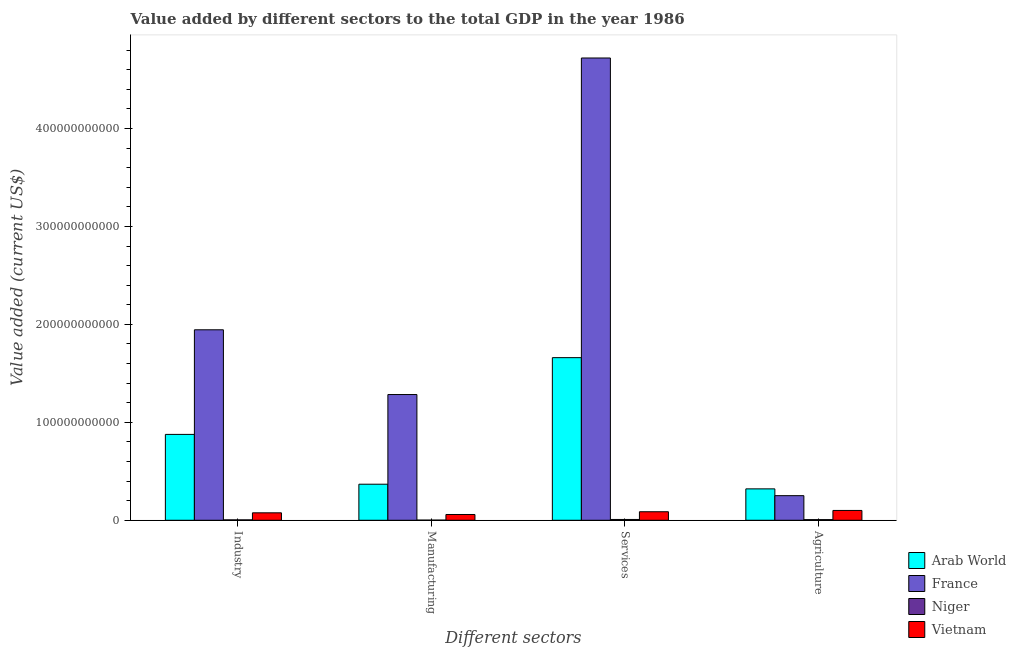How many different coloured bars are there?
Provide a succinct answer. 4. How many groups of bars are there?
Keep it short and to the point. 4. How many bars are there on the 3rd tick from the left?
Your response must be concise. 4. How many bars are there on the 1st tick from the right?
Your answer should be very brief. 4. What is the label of the 4th group of bars from the left?
Ensure brevity in your answer.  Agriculture. What is the value added by manufacturing sector in Vietnam?
Provide a short and direct response. 5.89e+09. Across all countries, what is the maximum value added by manufacturing sector?
Ensure brevity in your answer.  1.28e+11. Across all countries, what is the minimum value added by services sector?
Make the answer very short. 8.27e+08. In which country was the value added by agricultural sector maximum?
Keep it short and to the point. Arab World. In which country was the value added by services sector minimum?
Your answer should be very brief. Niger. What is the total value added by agricultural sector in the graph?
Your response must be concise. 6.79e+1. What is the difference between the value added by agricultural sector in France and that in Vietnam?
Give a very brief answer. 1.51e+1. What is the difference between the value added by agricultural sector in France and the value added by industrial sector in Niger?
Keep it short and to the point. 2.47e+1. What is the average value added by agricultural sector per country?
Offer a very short reply. 1.70e+1. What is the difference between the value added by services sector and value added by manufacturing sector in Arab World?
Offer a very short reply. 1.29e+11. In how many countries, is the value added by agricultural sector greater than 320000000000 US$?
Offer a terse response. 0. What is the ratio of the value added by industrial sector in Niger to that in Arab World?
Keep it short and to the point. 0. Is the difference between the value added by manufacturing sector in Vietnam and France greater than the difference between the value added by agricultural sector in Vietnam and France?
Your response must be concise. No. What is the difference between the highest and the second highest value added by agricultural sector?
Keep it short and to the point. 6.93e+09. What is the difference between the highest and the lowest value added by agricultural sector?
Provide a short and direct response. 3.14e+1. In how many countries, is the value added by agricultural sector greater than the average value added by agricultural sector taken over all countries?
Give a very brief answer. 2. Is the sum of the value added by industrial sector in Arab World and France greater than the maximum value added by services sector across all countries?
Your answer should be compact. No. What does the 3rd bar from the left in Agriculture represents?
Make the answer very short. Niger. What does the 2nd bar from the right in Manufacturing represents?
Your response must be concise. Niger. How many bars are there?
Offer a terse response. 16. Are all the bars in the graph horizontal?
Keep it short and to the point. No. How many countries are there in the graph?
Offer a very short reply. 4. What is the difference between two consecutive major ticks on the Y-axis?
Your answer should be compact. 1.00e+11. Does the graph contain any zero values?
Keep it short and to the point. No. Does the graph contain grids?
Your answer should be compact. No. How are the legend labels stacked?
Your response must be concise. Vertical. What is the title of the graph?
Your answer should be very brief. Value added by different sectors to the total GDP in the year 1986. Does "Latvia" appear as one of the legend labels in the graph?
Make the answer very short. No. What is the label or title of the X-axis?
Your response must be concise. Different sectors. What is the label or title of the Y-axis?
Offer a terse response. Value added (current US$). What is the Value added (current US$) in Arab World in Industry?
Your response must be concise. 8.77e+1. What is the Value added (current US$) in France in Industry?
Ensure brevity in your answer.  1.94e+11. What is the Value added (current US$) in Niger in Industry?
Your response must be concise. 4.16e+08. What is the Value added (current US$) in Vietnam in Industry?
Provide a succinct answer. 7.61e+09. What is the Value added (current US$) of Arab World in Manufacturing?
Give a very brief answer. 3.68e+1. What is the Value added (current US$) of France in Manufacturing?
Your answer should be compact. 1.28e+11. What is the Value added (current US$) in Niger in Manufacturing?
Make the answer very short. 1.48e+08. What is the Value added (current US$) of Vietnam in Manufacturing?
Provide a succinct answer. 5.89e+09. What is the Value added (current US$) of Arab World in Services?
Ensure brevity in your answer.  1.66e+11. What is the Value added (current US$) of France in Services?
Give a very brief answer. 4.72e+11. What is the Value added (current US$) in Niger in Services?
Your answer should be very brief. 8.27e+08. What is the Value added (current US$) of Vietnam in Services?
Make the answer very short. 8.71e+09. What is the Value added (current US$) in Arab World in Agriculture?
Your answer should be very brief. 3.21e+1. What is the Value added (current US$) in France in Agriculture?
Make the answer very short. 2.51e+1. What is the Value added (current US$) in Niger in Agriculture?
Your response must be concise. 6.61e+08. What is the Value added (current US$) in Vietnam in Agriculture?
Offer a terse response. 1.00e+1. Across all Different sectors, what is the maximum Value added (current US$) of Arab World?
Keep it short and to the point. 1.66e+11. Across all Different sectors, what is the maximum Value added (current US$) of France?
Your response must be concise. 4.72e+11. Across all Different sectors, what is the maximum Value added (current US$) of Niger?
Give a very brief answer. 8.27e+08. Across all Different sectors, what is the maximum Value added (current US$) in Vietnam?
Offer a terse response. 1.00e+1. Across all Different sectors, what is the minimum Value added (current US$) in Arab World?
Ensure brevity in your answer.  3.21e+1. Across all Different sectors, what is the minimum Value added (current US$) in France?
Keep it short and to the point. 2.51e+1. Across all Different sectors, what is the minimum Value added (current US$) in Niger?
Provide a short and direct response. 1.48e+08. Across all Different sectors, what is the minimum Value added (current US$) in Vietnam?
Your answer should be compact. 5.89e+09. What is the total Value added (current US$) of Arab World in the graph?
Offer a very short reply. 3.23e+11. What is the total Value added (current US$) in France in the graph?
Keep it short and to the point. 8.20e+11. What is the total Value added (current US$) of Niger in the graph?
Make the answer very short. 2.05e+09. What is the total Value added (current US$) in Vietnam in the graph?
Offer a terse response. 3.22e+1. What is the difference between the Value added (current US$) of Arab World in Industry and that in Manufacturing?
Offer a terse response. 5.09e+1. What is the difference between the Value added (current US$) of France in Industry and that in Manufacturing?
Your answer should be very brief. 6.61e+1. What is the difference between the Value added (current US$) of Niger in Industry and that in Manufacturing?
Provide a short and direct response. 2.68e+08. What is the difference between the Value added (current US$) of Vietnam in Industry and that in Manufacturing?
Your response must be concise. 1.71e+09. What is the difference between the Value added (current US$) in Arab World in Industry and that in Services?
Ensure brevity in your answer.  -7.84e+1. What is the difference between the Value added (current US$) of France in Industry and that in Services?
Keep it short and to the point. -2.78e+11. What is the difference between the Value added (current US$) in Niger in Industry and that in Services?
Your answer should be very brief. -4.11e+08. What is the difference between the Value added (current US$) of Vietnam in Industry and that in Services?
Make the answer very short. -1.10e+09. What is the difference between the Value added (current US$) of Arab World in Industry and that in Agriculture?
Offer a very short reply. 5.56e+1. What is the difference between the Value added (current US$) of France in Industry and that in Agriculture?
Your answer should be very brief. 1.69e+11. What is the difference between the Value added (current US$) of Niger in Industry and that in Agriculture?
Your answer should be compact. -2.45e+08. What is the difference between the Value added (current US$) in Vietnam in Industry and that in Agriculture?
Your response must be concise. -2.42e+09. What is the difference between the Value added (current US$) in Arab World in Manufacturing and that in Services?
Make the answer very short. -1.29e+11. What is the difference between the Value added (current US$) of France in Manufacturing and that in Services?
Ensure brevity in your answer.  -3.44e+11. What is the difference between the Value added (current US$) in Niger in Manufacturing and that in Services?
Your answer should be very brief. -6.79e+08. What is the difference between the Value added (current US$) in Vietnam in Manufacturing and that in Services?
Provide a succinct answer. -2.81e+09. What is the difference between the Value added (current US$) of Arab World in Manufacturing and that in Agriculture?
Your response must be concise. 4.75e+09. What is the difference between the Value added (current US$) in France in Manufacturing and that in Agriculture?
Give a very brief answer. 1.03e+11. What is the difference between the Value added (current US$) of Niger in Manufacturing and that in Agriculture?
Ensure brevity in your answer.  -5.14e+08. What is the difference between the Value added (current US$) of Vietnam in Manufacturing and that in Agriculture?
Offer a terse response. -4.13e+09. What is the difference between the Value added (current US$) in Arab World in Services and that in Agriculture?
Offer a very short reply. 1.34e+11. What is the difference between the Value added (current US$) in France in Services and that in Agriculture?
Your answer should be very brief. 4.47e+11. What is the difference between the Value added (current US$) of Niger in Services and that in Agriculture?
Give a very brief answer. 1.66e+08. What is the difference between the Value added (current US$) in Vietnam in Services and that in Agriculture?
Your answer should be compact. -1.32e+09. What is the difference between the Value added (current US$) of Arab World in Industry and the Value added (current US$) of France in Manufacturing?
Make the answer very short. -4.07e+1. What is the difference between the Value added (current US$) of Arab World in Industry and the Value added (current US$) of Niger in Manufacturing?
Provide a short and direct response. 8.75e+1. What is the difference between the Value added (current US$) in Arab World in Industry and the Value added (current US$) in Vietnam in Manufacturing?
Your answer should be very brief. 8.18e+1. What is the difference between the Value added (current US$) of France in Industry and the Value added (current US$) of Niger in Manufacturing?
Provide a short and direct response. 1.94e+11. What is the difference between the Value added (current US$) in France in Industry and the Value added (current US$) in Vietnam in Manufacturing?
Offer a very short reply. 1.89e+11. What is the difference between the Value added (current US$) of Niger in Industry and the Value added (current US$) of Vietnam in Manufacturing?
Keep it short and to the point. -5.48e+09. What is the difference between the Value added (current US$) of Arab World in Industry and the Value added (current US$) of France in Services?
Make the answer very short. -3.84e+11. What is the difference between the Value added (current US$) of Arab World in Industry and the Value added (current US$) of Niger in Services?
Offer a very short reply. 8.69e+1. What is the difference between the Value added (current US$) in Arab World in Industry and the Value added (current US$) in Vietnam in Services?
Your answer should be very brief. 7.90e+1. What is the difference between the Value added (current US$) in France in Industry and the Value added (current US$) in Niger in Services?
Make the answer very short. 1.94e+11. What is the difference between the Value added (current US$) of France in Industry and the Value added (current US$) of Vietnam in Services?
Ensure brevity in your answer.  1.86e+11. What is the difference between the Value added (current US$) in Niger in Industry and the Value added (current US$) in Vietnam in Services?
Your answer should be compact. -8.29e+09. What is the difference between the Value added (current US$) in Arab World in Industry and the Value added (current US$) in France in Agriculture?
Give a very brief answer. 6.26e+1. What is the difference between the Value added (current US$) in Arab World in Industry and the Value added (current US$) in Niger in Agriculture?
Give a very brief answer. 8.70e+1. What is the difference between the Value added (current US$) in Arab World in Industry and the Value added (current US$) in Vietnam in Agriculture?
Your answer should be compact. 7.77e+1. What is the difference between the Value added (current US$) in France in Industry and the Value added (current US$) in Niger in Agriculture?
Make the answer very short. 1.94e+11. What is the difference between the Value added (current US$) of France in Industry and the Value added (current US$) of Vietnam in Agriculture?
Provide a short and direct response. 1.84e+11. What is the difference between the Value added (current US$) of Niger in Industry and the Value added (current US$) of Vietnam in Agriculture?
Offer a very short reply. -9.61e+09. What is the difference between the Value added (current US$) in Arab World in Manufacturing and the Value added (current US$) in France in Services?
Your answer should be very brief. -4.35e+11. What is the difference between the Value added (current US$) in Arab World in Manufacturing and the Value added (current US$) in Niger in Services?
Ensure brevity in your answer.  3.60e+1. What is the difference between the Value added (current US$) of Arab World in Manufacturing and the Value added (current US$) of Vietnam in Services?
Your answer should be compact. 2.81e+1. What is the difference between the Value added (current US$) of France in Manufacturing and the Value added (current US$) of Niger in Services?
Provide a short and direct response. 1.28e+11. What is the difference between the Value added (current US$) in France in Manufacturing and the Value added (current US$) in Vietnam in Services?
Offer a very short reply. 1.20e+11. What is the difference between the Value added (current US$) in Niger in Manufacturing and the Value added (current US$) in Vietnam in Services?
Offer a terse response. -8.56e+09. What is the difference between the Value added (current US$) of Arab World in Manufacturing and the Value added (current US$) of France in Agriculture?
Provide a succinct answer. 1.17e+1. What is the difference between the Value added (current US$) of Arab World in Manufacturing and the Value added (current US$) of Niger in Agriculture?
Make the answer very short. 3.61e+1. What is the difference between the Value added (current US$) of Arab World in Manufacturing and the Value added (current US$) of Vietnam in Agriculture?
Give a very brief answer. 2.68e+1. What is the difference between the Value added (current US$) of France in Manufacturing and the Value added (current US$) of Niger in Agriculture?
Your answer should be compact. 1.28e+11. What is the difference between the Value added (current US$) of France in Manufacturing and the Value added (current US$) of Vietnam in Agriculture?
Your response must be concise. 1.18e+11. What is the difference between the Value added (current US$) of Niger in Manufacturing and the Value added (current US$) of Vietnam in Agriculture?
Provide a succinct answer. -9.88e+09. What is the difference between the Value added (current US$) of Arab World in Services and the Value added (current US$) of France in Agriculture?
Your answer should be compact. 1.41e+11. What is the difference between the Value added (current US$) of Arab World in Services and the Value added (current US$) of Niger in Agriculture?
Ensure brevity in your answer.  1.65e+11. What is the difference between the Value added (current US$) in Arab World in Services and the Value added (current US$) in Vietnam in Agriculture?
Your response must be concise. 1.56e+11. What is the difference between the Value added (current US$) of France in Services and the Value added (current US$) of Niger in Agriculture?
Your response must be concise. 4.71e+11. What is the difference between the Value added (current US$) in France in Services and the Value added (current US$) in Vietnam in Agriculture?
Make the answer very short. 4.62e+11. What is the difference between the Value added (current US$) of Niger in Services and the Value added (current US$) of Vietnam in Agriculture?
Offer a terse response. -9.20e+09. What is the average Value added (current US$) in Arab World per Different sectors?
Give a very brief answer. 8.07e+1. What is the average Value added (current US$) in France per Different sectors?
Offer a terse response. 2.05e+11. What is the average Value added (current US$) of Niger per Different sectors?
Your response must be concise. 5.13e+08. What is the average Value added (current US$) in Vietnam per Different sectors?
Your answer should be compact. 8.06e+09. What is the difference between the Value added (current US$) of Arab World and Value added (current US$) of France in Industry?
Make the answer very short. -1.07e+11. What is the difference between the Value added (current US$) in Arab World and Value added (current US$) in Niger in Industry?
Ensure brevity in your answer.  8.73e+1. What is the difference between the Value added (current US$) of Arab World and Value added (current US$) of Vietnam in Industry?
Your answer should be compact. 8.01e+1. What is the difference between the Value added (current US$) of France and Value added (current US$) of Niger in Industry?
Your answer should be very brief. 1.94e+11. What is the difference between the Value added (current US$) in France and Value added (current US$) in Vietnam in Industry?
Offer a very short reply. 1.87e+11. What is the difference between the Value added (current US$) in Niger and Value added (current US$) in Vietnam in Industry?
Your response must be concise. -7.19e+09. What is the difference between the Value added (current US$) of Arab World and Value added (current US$) of France in Manufacturing?
Provide a short and direct response. -9.16e+1. What is the difference between the Value added (current US$) in Arab World and Value added (current US$) in Niger in Manufacturing?
Your answer should be very brief. 3.67e+1. What is the difference between the Value added (current US$) in Arab World and Value added (current US$) in Vietnam in Manufacturing?
Offer a terse response. 3.09e+1. What is the difference between the Value added (current US$) of France and Value added (current US$) of Niger in Manufacturing?
Provide a short and direct response. 1.28e+11. What is the difference between the Value added (current US$) of France and Value added (current US$) of Vietnam in Manufacturing?
Ensure brevity in your answer.  1.22e+11. What is the difference between the Value added (current US$) in Niger and Value added (current US$) in Vietnam in Manufacturing?
Give a very brief answer. -5.74e+09. What is the difference between the Value added (current US$) of Arab World and Value added (current US$) of France in Services?
Provide a succinct answer. -3.06e+11. What is the difference between the Value added (current US$) in Arab World and Value added (current US$) in Niger in Services?
Offer a terse response. 1.65e+11. What is the difference between the Value added (current US$) of Arab World and Value added (current US$) of Vietnam in Services?
Make the answer very short. 1.57e+11. What is the difference between the Value added (current US$) of France and Value added (current US$) of Niger in Services?
Your answer should be very brief. 4.71e+11. What is the difference between the Value added (current US$) in France and Value added (current US$) in Vietnam in Services?
Your answer should be compact. 4.63e+11. What is the difference between the Value added (current US$) of Niger and Value added (current US$) of Vietnam in Services?
Make the answer very short. -7.88e+09. What is the difference between the Value added (current US$) in Arab World and Value added (current US$) in France in Agriculture?
Provide a succinct answer. 6.93e+09. What is the difference between the Value added (current US$) of Arab World and Value added (current US$) of Niger in Agriculture?
Your response must be concise. 3.14e+1. What is the difference between the Value added (current US$) in Arab World and Value added (current US$) in Vietnam in Agriculture?
Offer a terse response. 2.20e+1. What is the difference between the Value added (current US$) of France and Value added (current US$) of Niger in Agriculture?
Your answer should be compact. 2.45e+1. What is the difference between the Value added (current US$) of France and Value added (current US$) of Vietnam in Agriculture?
Your answer should be very brief. 1.51e+1. What is the difference between the Value added (current US$) in Niger and Value added (current US$) in Vietnam in Agriculture?
Ensure brevity in your answer.  -9.36e+09. What is the ratio of the Value added (current US$) of Arab World in Industry to that in Manufacturing?
Offer a terse response. 2.38. What is the ratio of the Value added (current US$) in France in Industry to that in Manufacturing?
Your response must be concise. 1.51. What is the ratio of the Value added (current US$) of Niger in Industry to that in Manufacturing?
Ensure brevity in your answer.  2.82. What is the ratio of the Value added (current US$) in Vietnam in Industry to that in Manufacturing?
Make the answer very short. 1.29. What is the ratio of the Value added (current US$) of Arab World in Industry to that in Services?
Ensure brevity in your answer.  0.53. What is the ratio of the Value added (current US$) in France in Industry to that in Services?
Keep it short and to the point. 0.41. What is the ratio of the Value added (current US$) in Niger in Industry to that in Services?
Your answer should be compact. 0.5. What is the ratio of the Value added (current US$) in Vietnam in Industry to that in Services?
Offer a terse response. 0.87. What is the ratio of the Value added (current US$) in Arab World in Industry to that in Agriculture?
Offer a very short reply. 2.73. What is the ratio of the Value added (current US$) in France in Industry to that in Agriculture?
Give a very brief answer. 7.74. What is the ratio of the Value added (current US$) of Niger in Industry to that in Agriculture?
Provide a succinct answer. 0.63. What is the ratio of the Value added (current US$) in Vietnam in Industry to that in Agriculture?
Offer a very short reply. 0.76. What is the ratio of the Value added (current US$) in Arab World in Manufacturing to that in Services?
Provide a succinct answer. 0.22. What is the ratio of the Value added (current US$) of France in Manufacturing to that in Services?
Your answer should be very brief. 0.27. What is the ratio of the Value added (current US$) of Niger in Manufacturing to that in Services?
Provide a succinct answer. 0.18. What is the ratio of the Value added (current US$) of Vietnam in Manufacturing to that in Services?
Offer a terse response. 0.68. What is the ratio of the Value added (current US$) in Arab World in Manufacturing to that in Agriculture?
Provide a short and direct response. 1.15. What is the ratio of the Value added (current US$) in France in Manufacturing to that in Agriculture?
Your response must be concise. 5.11. What is the ratio of the Value added (current US$) of Niger in Manufacturing to that in Agriculture?
Provide a succinct answer. 0.22. What is the ratio of the Value added (current US$) of Vietnam in Manufacturing to that in Agriculture?
Ensure brevity in your answer.  0.59. What is the ratio of the Value added (current US$) in Arab World in Services to that in Agriculture?
Your response must be concise. 5.18. What is the ratio of the Value added (current US$) of France in Services to that in Agriculture?
Give a very brief answer. 18.79. What is the ratio of the Value added (current US$) in Niger in Services to that in Agriculture?
Offer a very short reply. 1.25. What is the ratio of the Value added (current US$) in Vietnam in Services to that in Agriculture?
Your answer should be very brief. 0.87. What is the difference between the highest and the second highest Value added (current US$) of Arab World?
Provide a short and direct response. 7.84e+1. What is the difference between the highest and the second highest Value added (current US$) of France?
Provide a short and direct response. 2.78e+11. What is the difference between the highest and the second highest Value added (current US$) of Niger?
Make the answer very short. 1.66e+08. What is the difference between the highest and the second highest Value added (current US$) in Vietnam?
Your answer should be compact. 1.32e+09. What is the difference between the highest and the lowest Value added (current US$) in Arab World?
Your response must be concise. 1.34e+11. What is the difference between the highest and the lowest Value added (current US$) in France?
Offer a very short reply. 4.47e+11. What is the difference between the highest and the lowest Value added (current US$) in Niger?
Keep it short and to the point. 6.79e+08. What is the difference between the highest and the lowest Value added (current US$) in Vietnam?
Offer a terse response. 4.13e+09. 